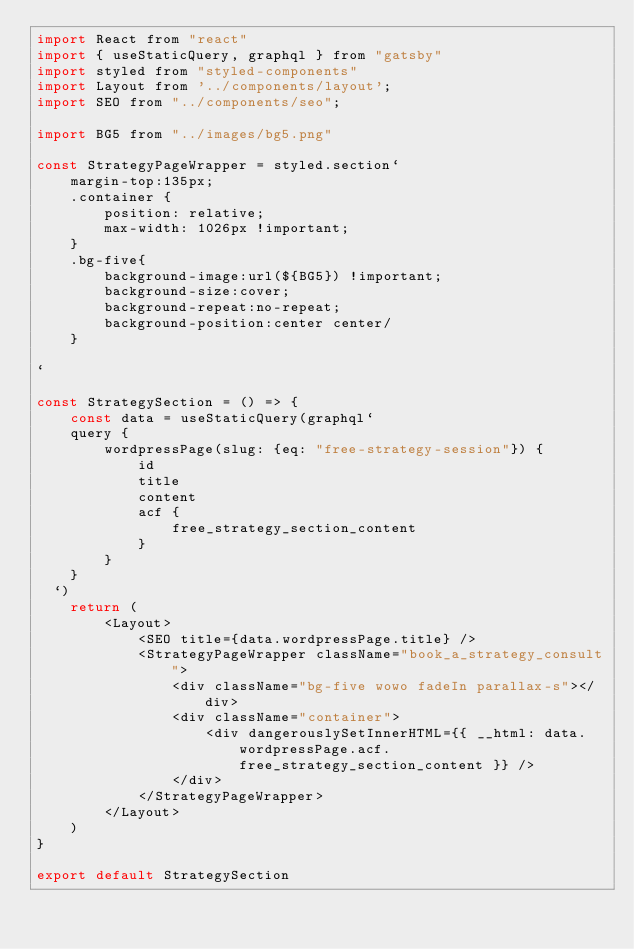Convert code to text. <code><loc_0><loc_0><loc_500><loc_500><_JavaScript_>import React from "react"
import { useStaticQuery, graphql } from "gatsby"
import styled from "styled-components"
import Layout from '../components/layout';
import SEO from "../components/seo";

import BG5 from "../images/bg5.png"

const StrategyPageWrapper = styled.section`
    margin-top:135px;
    .container {
        position: relative;
        max-width: 1026px !important;
    }
    .bg-five{
        background-image:url(${BG5}) !important;
        background-size:cover;
        background-repeat:no-repeat;
        background-position:center center/
    }

`

const StrategySection = () => {
    const data = useStaticQuery(graphql`
	query {
        wordpressPage(slug: {eq: "free-strategy-session"}) {
			id
			title
            content
            acf {
                free_strategy_section_content
            }
		}
	}
  `)
    return (
        <Layout>
            <SEO title={data.wordpressPage.title} />
            <StrategyPageWrapper className="book_a_strategy_consult">
                <div className="bg-five wowo fadeIn parallax-s"></div>
                <div className="container">
                    <div dangerouslySetInnerHTML={{ __html: data.wordpressPage.acf.free_strategy_section_content }} />
                </div>
            </StrategyPageWrapper>
        </Layout>
    )
}

export default StrategySection
</code> 